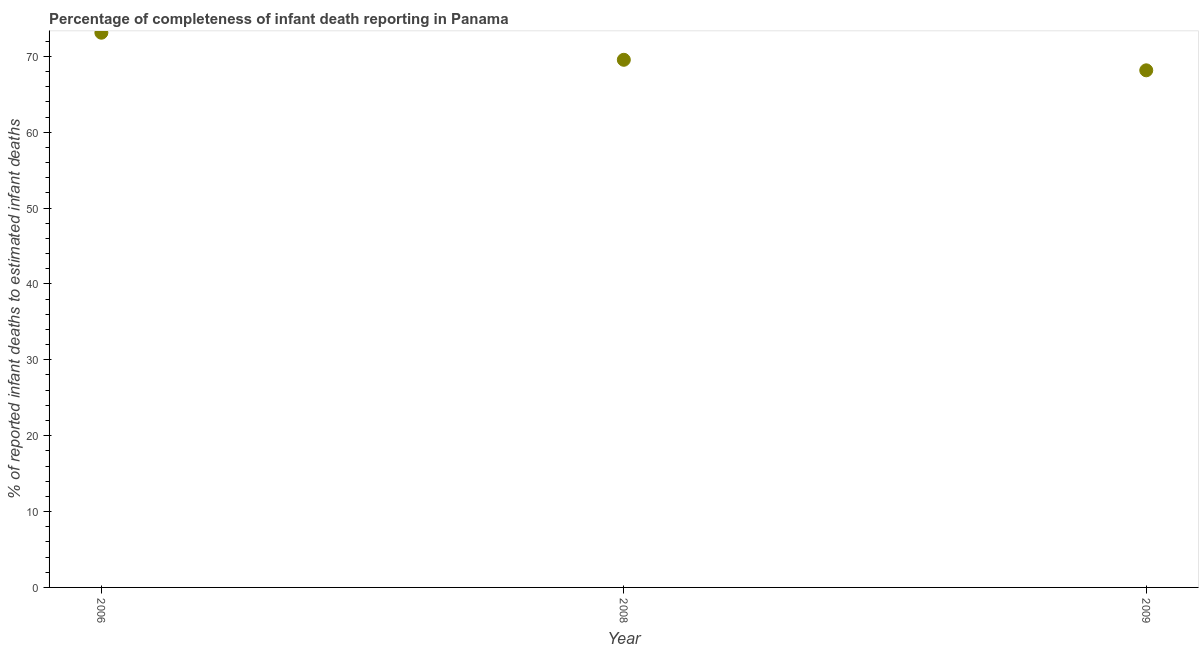What is the completeness of infant death reporting in 2009?
Keep it short and to the point. 68.16. Across all years, what is the maximum completeness of infant death reporting?
Offer a very short reply. 73.12. Across all years, what is the minimum completeness of infant death reporting?
Make the answer very short. 68.16. In which year was the completeness of infant death reporting maximum?
Offer a very short reply. 2006. In which year was the completeness of infant death reporting minimum?
Provide a succinct answer. 2009. What is the sum of the completeness of infant death reporting?
Offer a terse response. 210.83. What is the difference between the completeness of infant death reporting in 2008 and 2009?
Your answer should be compact. 1.39. What is the average completeness of infant death reporting per year?
Give a very brief answer. 70.28. What is the median completeness of infant death reporting?
Give a very brief answer. 69.55. Do a majority of the years between 2006 and 2008 (inclusive) have completeness of infant death reporting greater than 38 %?
Make the answer very short. Yes. What is the ratio of the completeness of infant death reporting in 2006 to that in 2008?
Give a very brief answer. 1.05. Is the completeness of infant death reporting in 2006 less than that in 2009?
Ensure brevity in your answer.  No. Is the difference between the completeness of infant death reporting in 2008 and 2009 greater than the difference between any two years?
Make the answer very short. No. What is the difference between the highest and the second highest completeness of infant death reporting?
Your response must be concise. 3.57. Is the sum of the completeness of infant death reporting in 2008 and 2009 greater than the maximum completeness of infant death reporting across all years?
Your response must be concise. Yes. What is the difference between the highest and the lowest completeness of infant death reporting?
Offer a very short reply. 4.96. Does the completeness of infant death reporting monotonically increase over the years?
Offer a terse response. No. How many dotlines are there?
Keep it short and to the point. 1. How many years are there in the graph?
Your response must be concise. 3. Are the values on the major ticks of Y-axis written in scientific E-notation?
Give a very brief answer. No. Does the graph contain grids?
Provide a short and direct response. No. What is the title of the graph?
Provide a short and direct response. Percentage of completeness of infant death reporting in Panama. What is the label or title of the X-axis?
Your response must be concise. Year. What is the label or title of the Y-axis?
Offer a terse response. % of reported infant deaths to estimated infant deaths. What is the % of reported infant deaths to estimated infant deaths in 2006?
Provide a succinct answer. 73.12. What is the % of reported infant deaths to estimated infant deaths in 2008?
Your answer should be very brief. 69.55. What is the % of reported infant deaths to estimated infant deaths in 2009?
Offer a very short reply. 68.16. What is the difference between the % of reported infant deaths to estimated infant deaths in 2006 and 2008?
Provide a short and direct response. 3.57. What is the difference between the % of reported infant deaths to estimated infant deaths in 2006 and 2009?
Offer a terse response. 4.96. What is the difference between the % of reported infant deaths to estimated infant deaths in 2008 and 2009?
Your response must be concise. 1.39. What is the ratio of the % of reported infant deaths to estimated infant deaths in 2006 to that in 2008?
Your answer should be very brief. 1.05. What is the ratio of the % of reported infant deaths to estimated infant deaths in 2006 to that in 2009?
Your response must be concise. 1.07. What is the ratio of the % of reported infant deaths to estimated infant deaths in 2008 to that in 2009?
Offer a terse response. 1.02. 